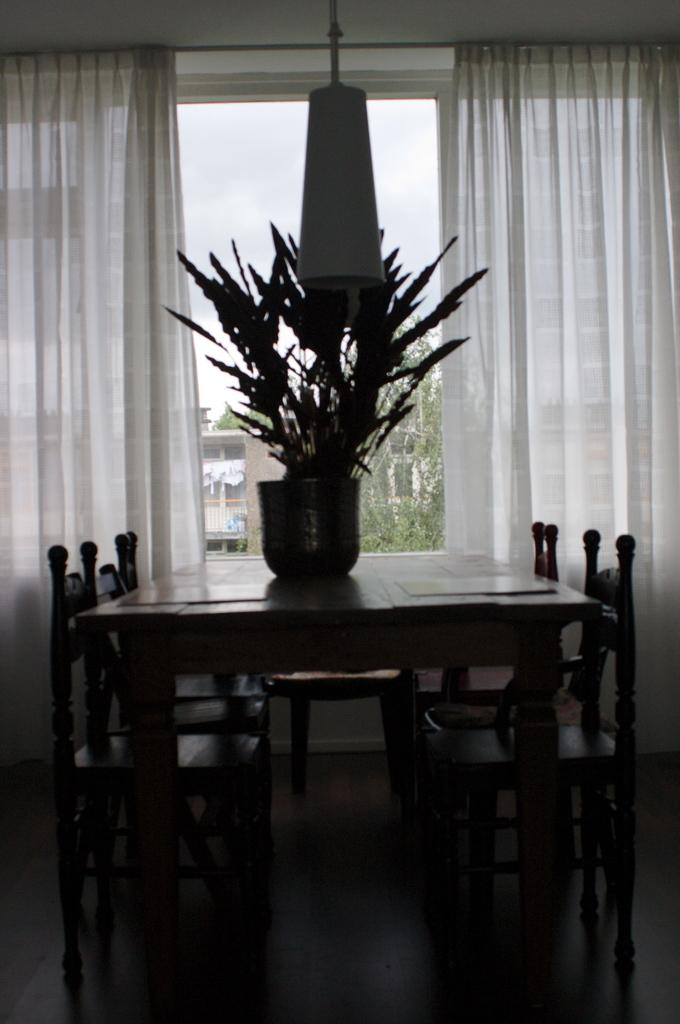What can be seen in the image that represents a plant? There is a flower in the image. What is the flower placed in? There is a flower vase in the image. What type of furniture is present in the image? There is a table and chairs in the image. What can be seen in the background of the image? There are curtains on a window in the background of the image. What type of produce is being sold in the image? There is no produce being sold in the image; it features a flower, vase, table, chairs, and curtains on a window. What type of amusement can be seen in the image? There is no amusement present in the image; it features a flower, vase, table, chairs, and curtains on a window. 